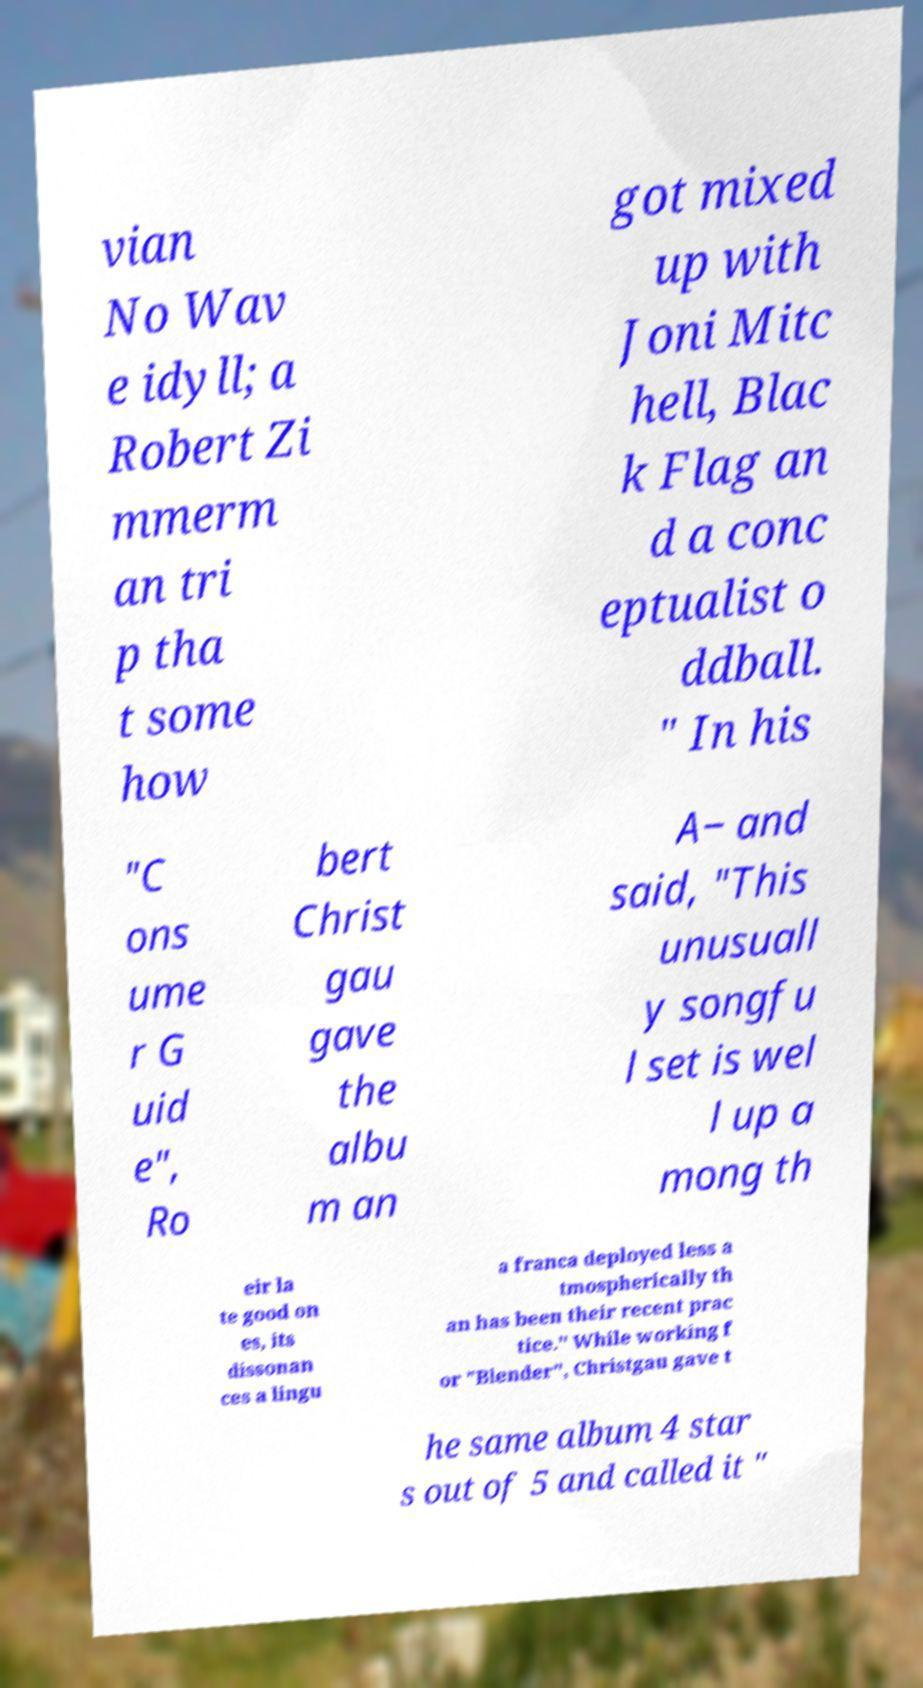Can you read and provide the text displayed in the image?This photo seems to have some interesting text. Can you extract and type it out for me? vian No Wav e idyll; a Robert Zi mmerm an tri p tha t some how got mixed up with Joni Mitc hell, Blac k Flag an d a conc eptualist o ddball. " In his "C ons ume r G uid e", Ro bert Christ gau gave the albu m an A− and said, "This unusuall y songfu l set is wel l up a mong th eir la te good on es, its dissonan ces a lingu a franca deployed less a tmospherically th an has been their recent prac tice." While working f or "Blender", Christgau gave t he same album 4 star s out of 5 and called it " 